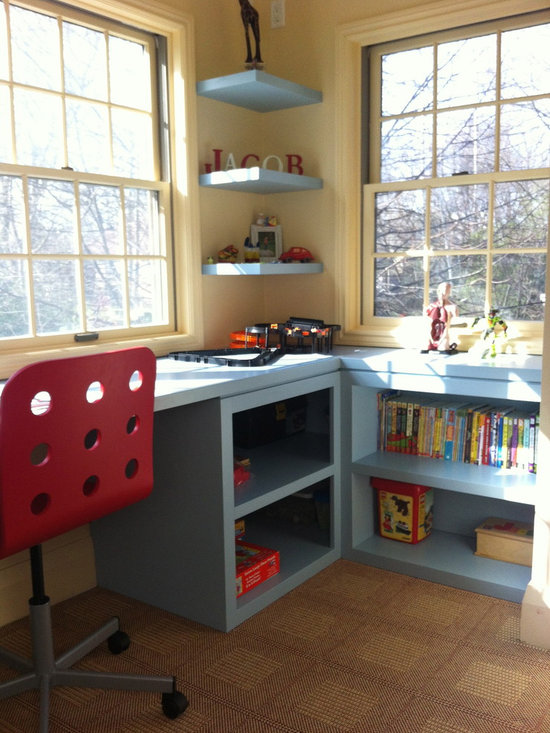Considering the items on the desk and shelves, what might be the age range of the individual who uses this space, and what are the indicators that lead to this conclusion? The age range of the individual likely using this space is that of a young child, possibly between 4 to 10 years old. This conclusion is drawn from several indicators: the presence of a toy train set on the desk, a shelf stocked with colorful children's books, and the playful design of the nameplate with block letters. Additionally, the presence of a computer monitor suggests that the child could be of school age, as it may be used for educational purposes or entertainment suitable for that age range. 